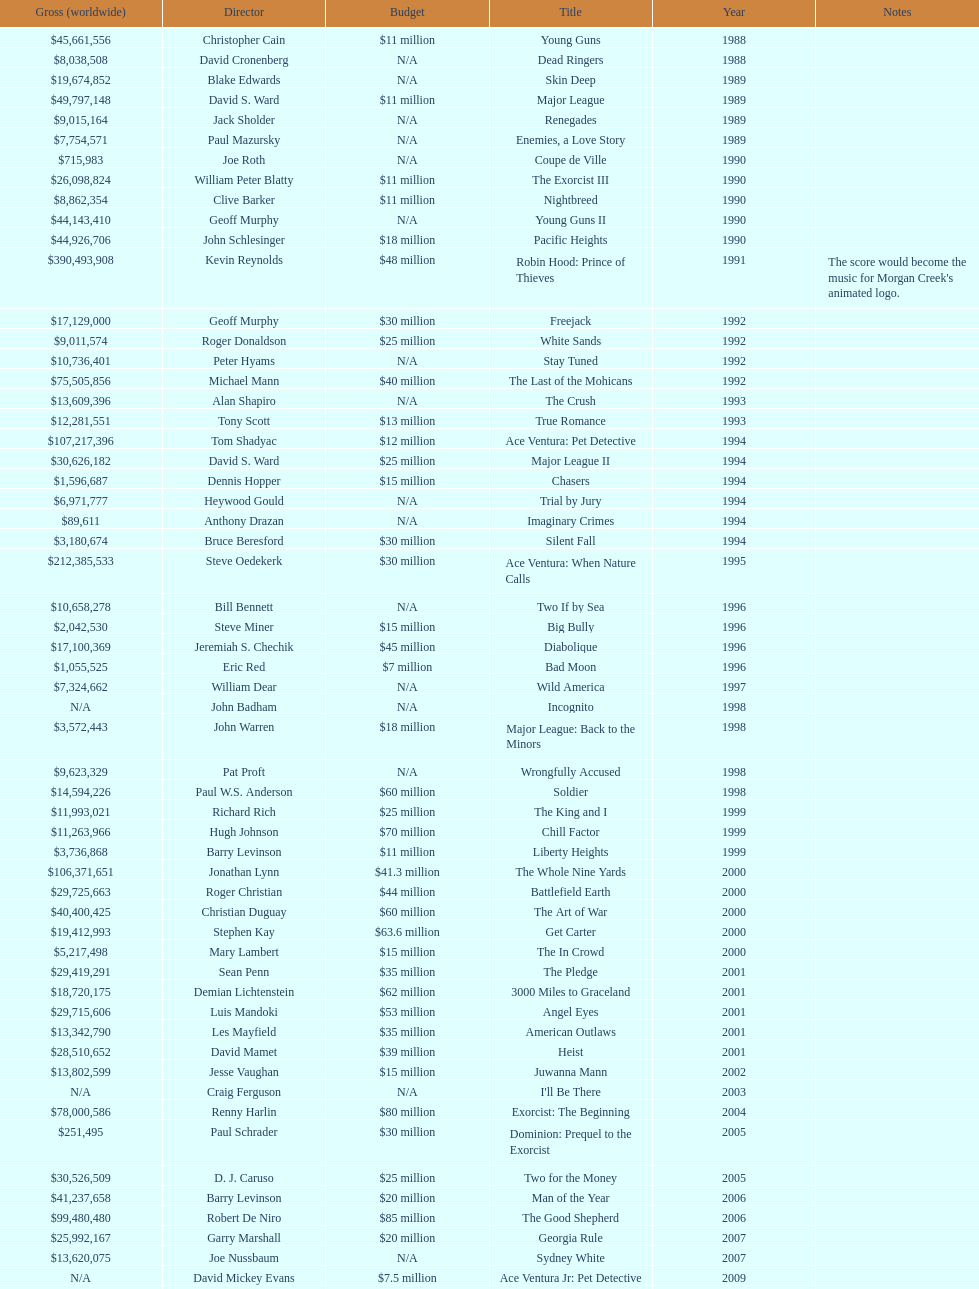Did true romance make more or less money than diabolique? Less. 